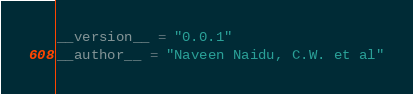<code> <loc_0><loc_0><loc_500><loc_500><_Python_>__version__ = "0.0.1"
__author__ = "Naveen Naidu, C.W. et al"
</code> 